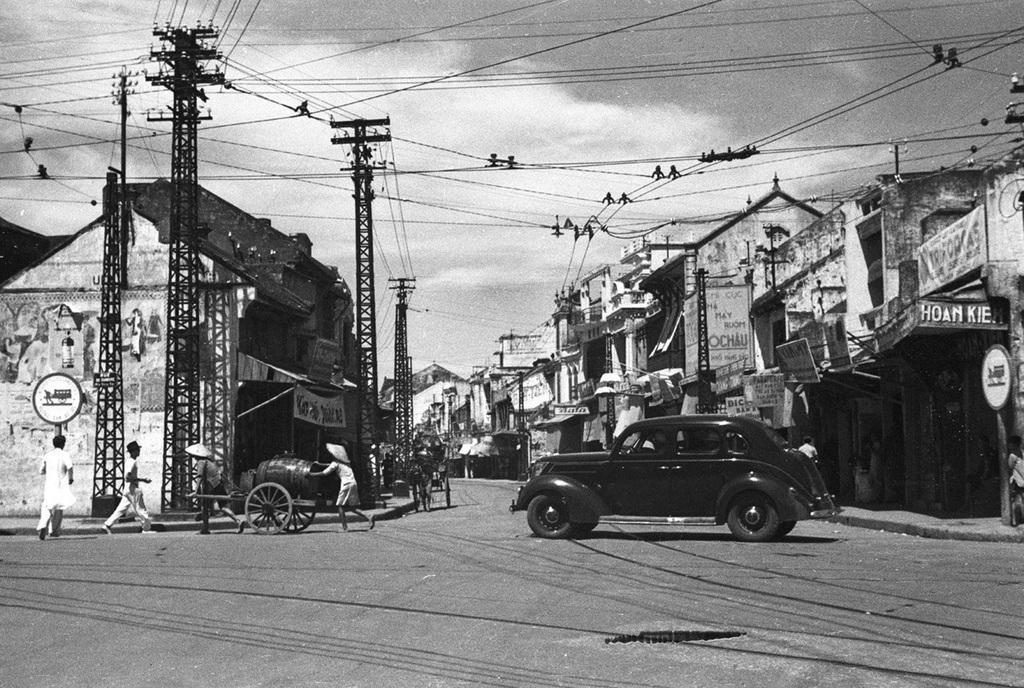Could you give a brief overview of what you see in this image? There are people walking and this person holding cart and we can see car on the road. We can see towers with wires and boards. Background we can see houses and sky with clouds. 